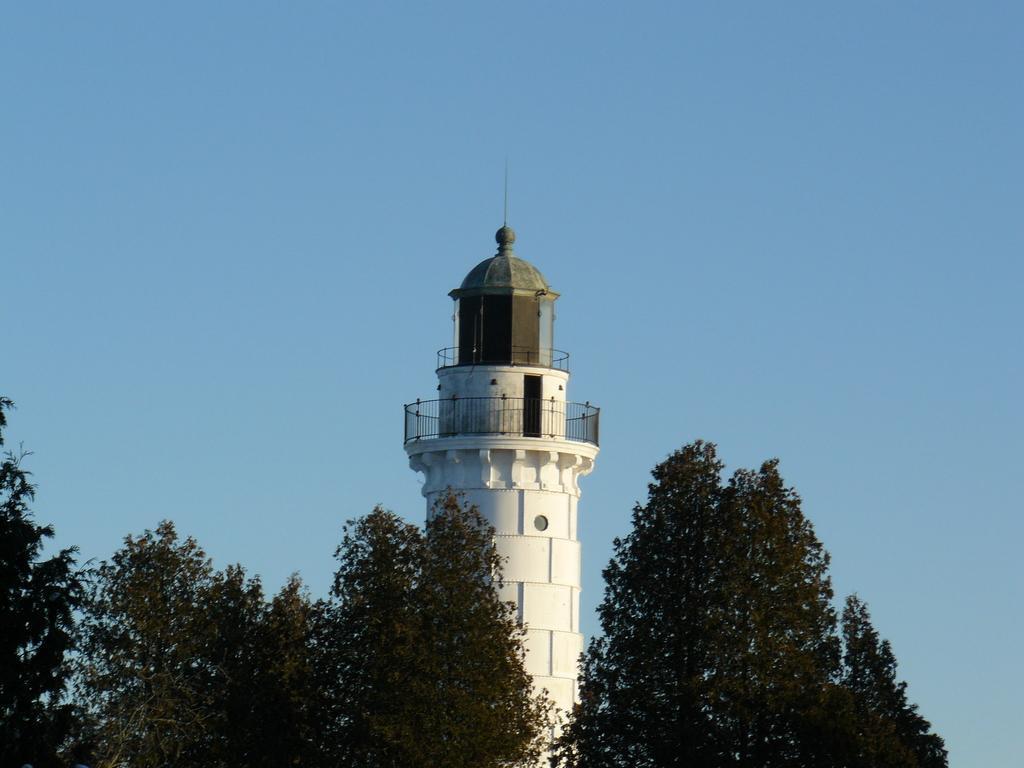In one or two sentences, can you explain what this image depicts? In this image there are trees to the bottom. In the center there is a tower. At the top the tower there is a railing. At the top there is the sky. 